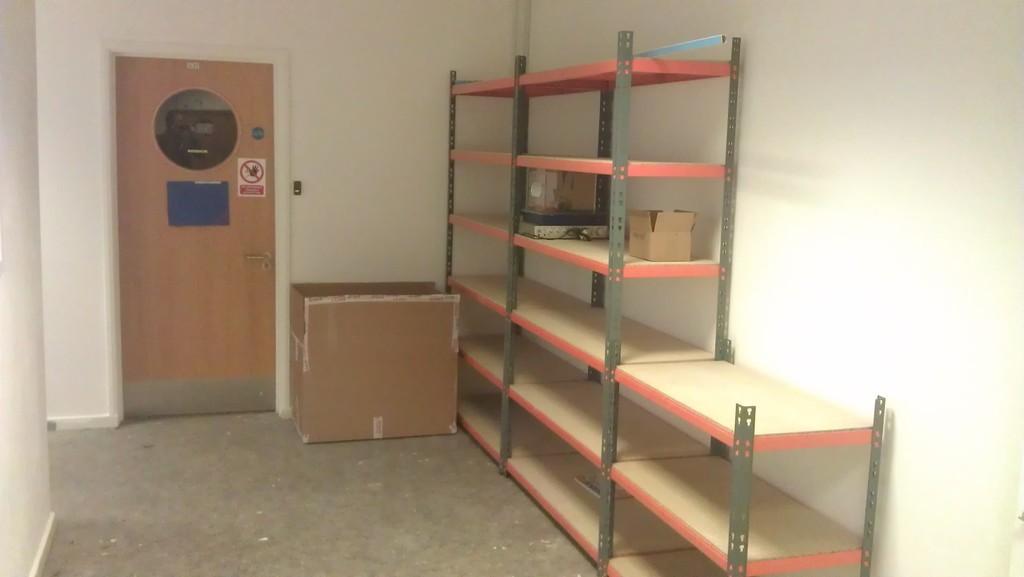Describe this image in one or two sentences. In this image there is a rack and few objects placed in it, beside that there is a box made up of cardboard and in the background there is a wall and a closed door. 